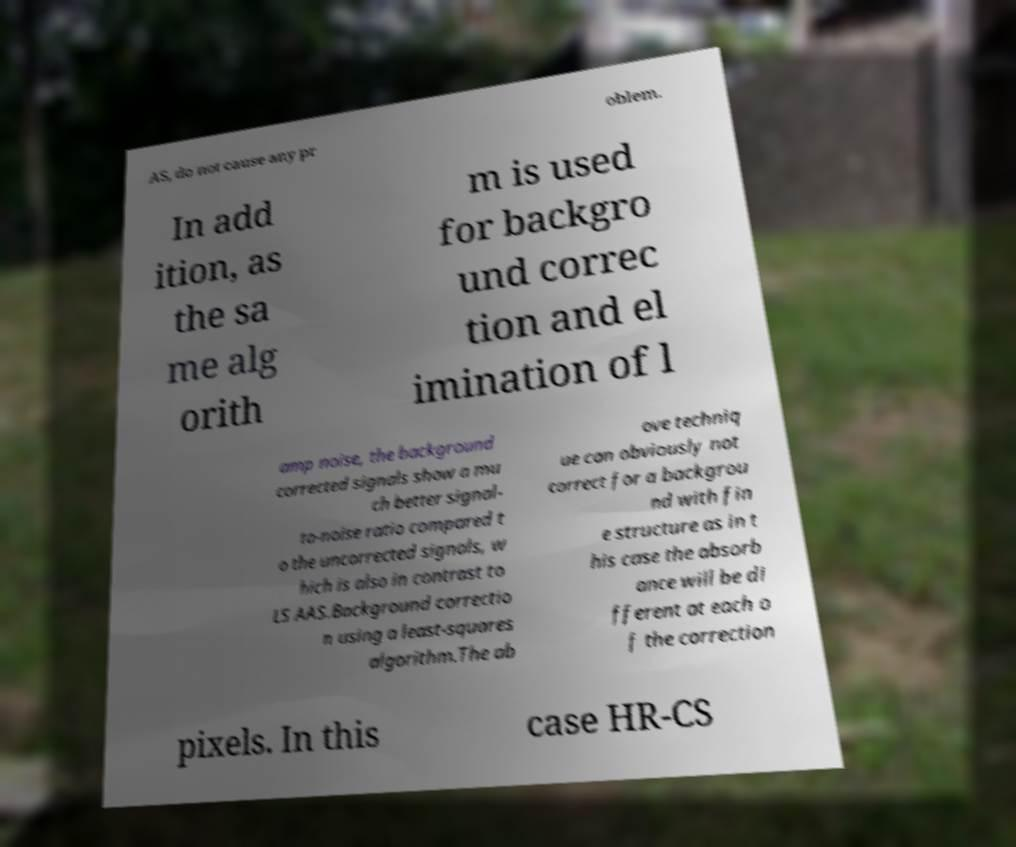I need the written content from this picture converted into text. Can you do that? AS, do not cause any pr oblem. In add ition, as the sa me alg orith m is used for backgro und correc tion and el imination of l amp noise, the background corrected signals show a mu ch better signal- to-noise ratio compared t o the uncorrected signals, w hich is also in contrast to LS AAS.Background correctio n using a least-squares algorithm.The ab ove techniq ue can obviously not correct for a backgrou nd with fin e structure as in t his case the absorb ance will be di fferent at each o f the correction pixels. In this case HR-CS 